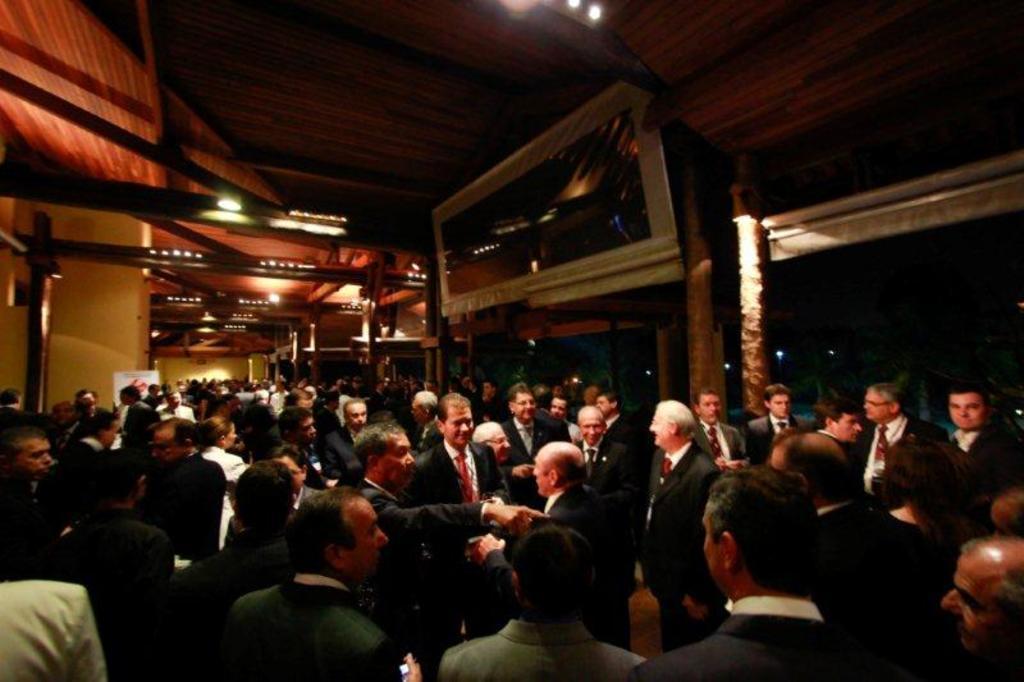Can you describe this image briefly? In this image we can see people standing and there are doors. We can see pillars. In the background there is a wall and lights. 